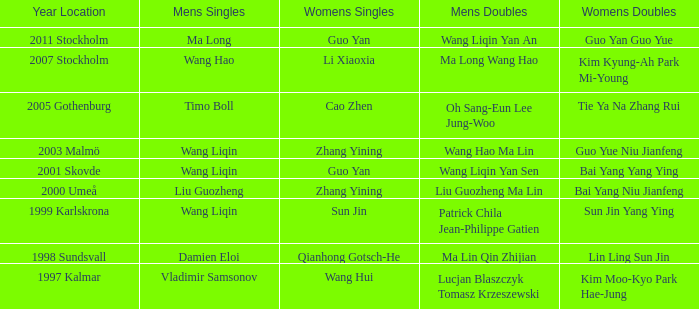How many occasions has ma long triumphed in the men's singles? 1.0. 